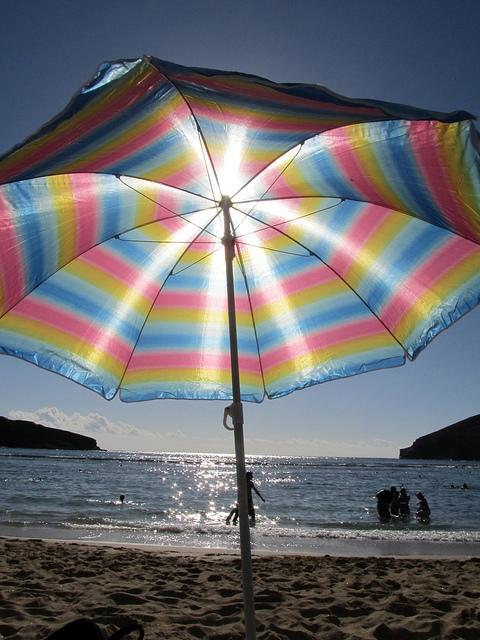What is planted in the sand? umbrella 